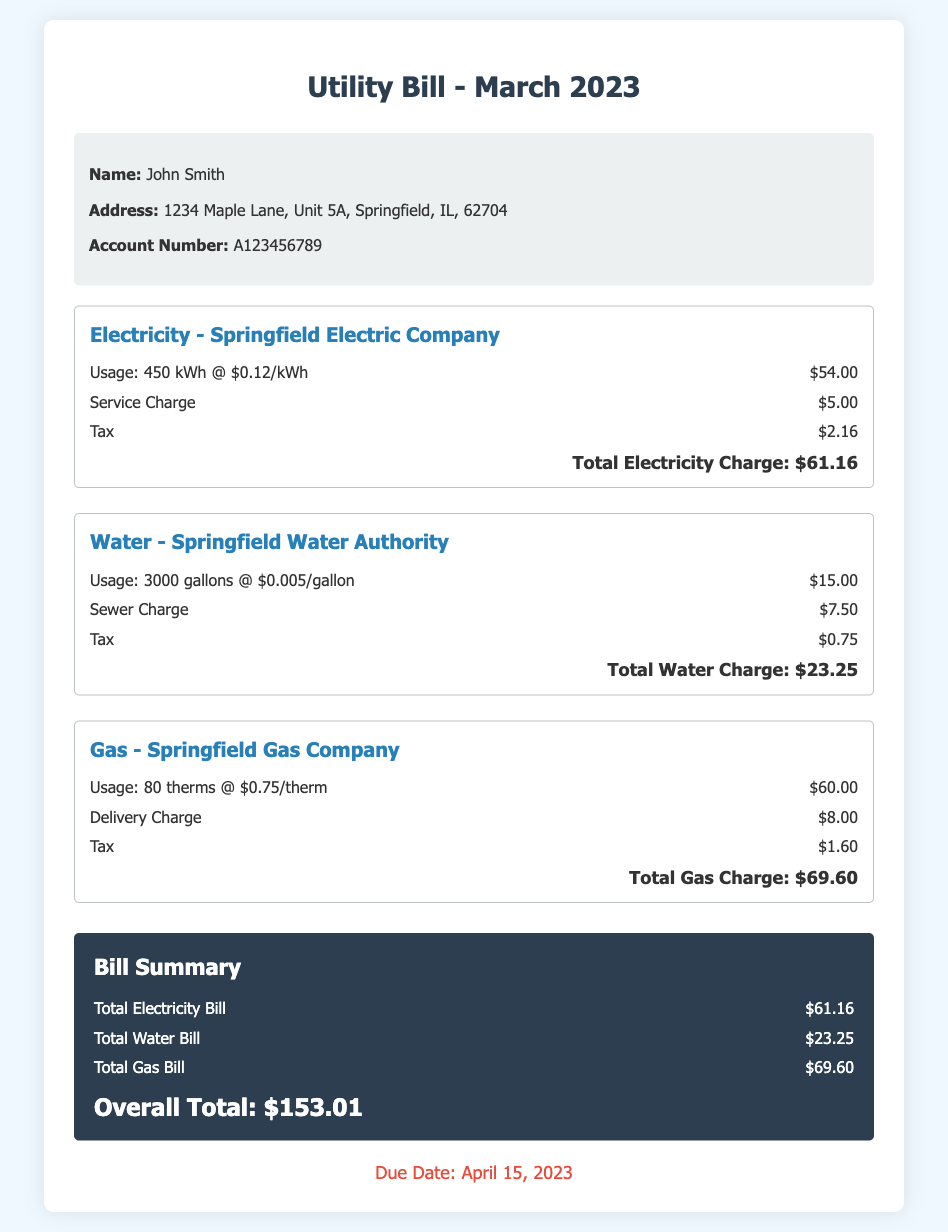what is the name of the utility company for electricity? The document states that the electricity provider is Springfield Electric Company.
Answer: Springfield Electric Company how much was the service charge for electricity? According to the electricity section, the service charge is listed as $5.00.
Answer: $5.00 what is the total water charge? The total water charge is provided in the water section, which is $23.25.
Answer: $23.25 how many gallons of water were used? The document specifies that 3000 gallons of water were used.
Answer: 3000 gallons what is the overall total for the utility bill? The overall total is calculated by summing the individual totals for electricity, water, and gas, which is shown as $153.01.
Answer: $153.01 what is the due date for the utility bill? The document indicates that the due date is April 15, 2023.
Answer: April 15, 2023 how much is the tax for the gas charge? The tax for the gas charge, as detailed in the gas section, is $1.60.
Answer: $1.60 what is the rate per therm for gas? The usage details in the gas section show that the rate is $0.75 per therm.
Answer: $0.75 per therm what is the total electricity charge? The total electricity charge is reported as $61.16 in the electricity section.
Answer: $61.16 